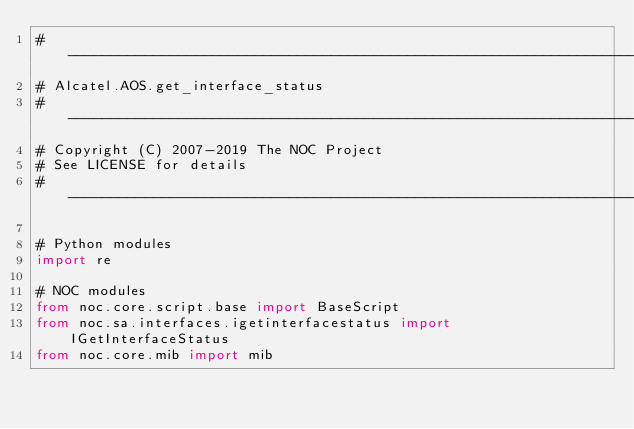Convert code to text. <code><loc_0><loc_0><loc_500><loc_500><_Python_># ----------------------------------------------------------------------
# Alcatel.AOS.get_interface_status
# ----------------------------------------------------------------------
# Copyright (C) 2007-2019 The NOC Project
# See LICENSE for details
# ----------------------------------------------------------------------

# Python modules
import re

# NOC modules
from noc.core.script.base import BaseScript
from noc.sa.interfaces.igetinterfacestatus import IGetInterfaceStatus
from noc.core.mib import mib

</code> 